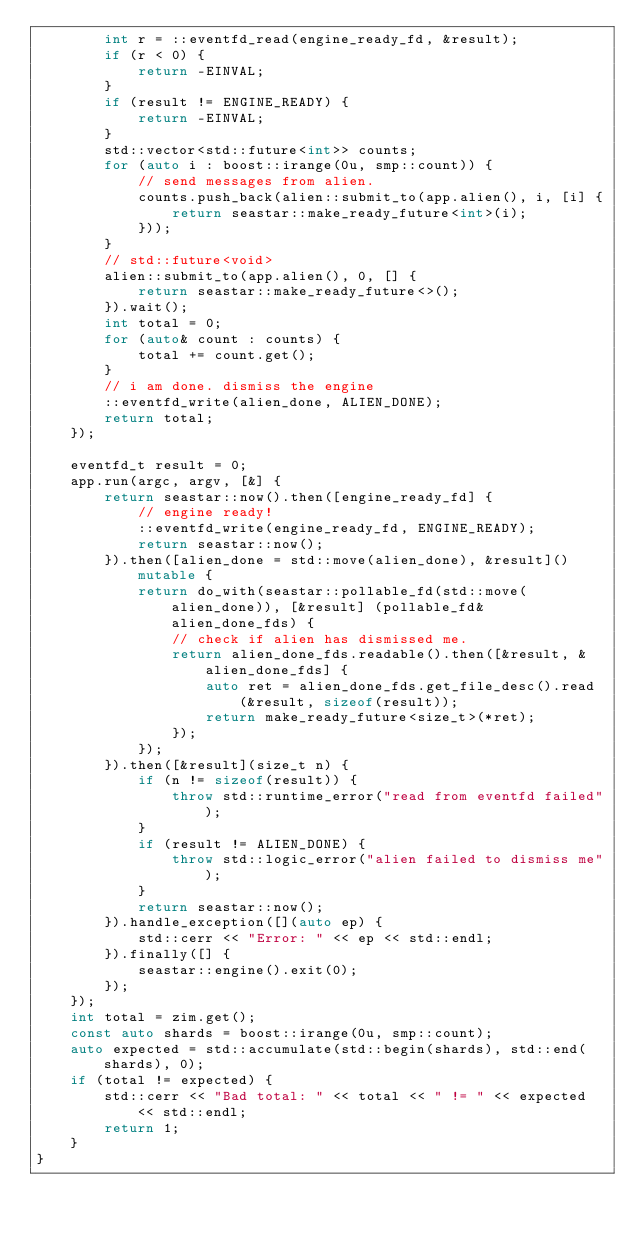<code> <loc_0><loc_0><loc_500><loc_500><_C++_>        int r = ::eventfd_read(engine_ready_fd, &result);
        if (r < 0) {
            return -EINVAL;
        }
        if (result != ENGINE_READY) {
            return -EINVAL;
        }
        std::vector<std::future<int>> counts;
        for (auto i : boost::irange(0u, smp::count)) {
            // send messages from alien.
            counts.push_back(alien::submit_to(app.alien(), i, [i] {
                return seastar::make_ready_future<int>(i);
            }));
        }
        // std::future<void>
        alien::submit_to(app.alien(), 0, [] {
            return seastar::make_ready_future<>();
        }).wait();
        int total = 0;
        for (auto& count : counts) {
            total += count.get();
        }
        // i am done. dismiss the engine
        ::eventfd_write(alien_done, ALIEN_DONE);
        return total;
    });

    eventfd_t result = 0;
    app.run(argc, argv, [&] {
        return seastar::now().then([engine_ready_fd] {
            // engine ready!
            ::eventfd_write(engine_ready_fd, ENGINE_READY);
            return seastar::now();
        }).then([alien_done = std::move(alien_done), &result]() mutable {
            return do_with(seastar::pollable_fd(std::move(alien_done)), [&result] (pollable_fd& alien_done_fds) {
                // check if alien has dismissed me.
                return alien_done_fds.readable().then([&result, &alien_done_fds] {
                    auto ret = alien_done_fds.get_file_desc().read(&result, sizeof(result));
                    return make_ready_future<size_t>(*ret);
                });
            });
        }).then([&result](size_t n) {
            if (n != sizeof(result)) {
                throw std::runtime_error("read from eventfd failed");
            }
            if (result != ALIEN_DONE) {
                throw std::logic_error("alien failed to dismiss me");
            }
            return seastar::now();
        }).handle_exception([](auto ep) {
            std::cerr << "Error: " << ep << std::endl;
        }).finally([] {
            seastar::engine().exit(0);
        });
    });
    int total = zim.get();
    const auto shards = boost::irange(0u, smp::count);
    auto expected = std::accumulate(std::begin(shards), std::end(shards), 0);
    if (total != expected) {
        std::cerr << "Bad total: " << total << " != " << expected << std::endl;
        return 1;
    }
}
</code> 